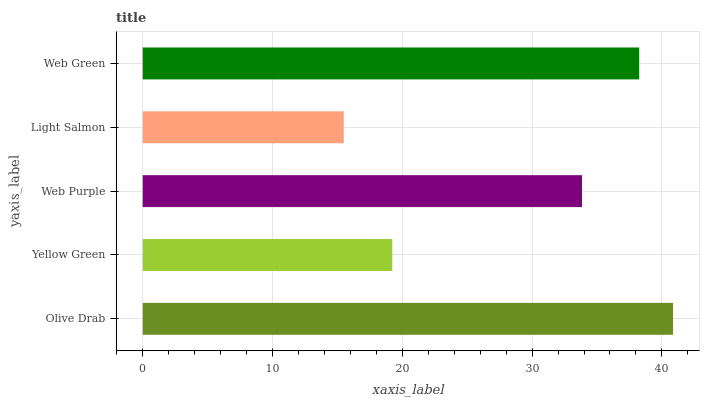Is Light Salmon the minimum?
Answer yes or no. Yes. Is Olive Drab the maximum?
Answer yes or no. Yes. Is Yellow Green the minimum?
Answer yes or no. No. Is Yellow Green the maximum?
Answer yes or no. No. Is Olive Drab greater than Yellow Green?
Answer yes or no. Yes. Is Yellow Green less than Olive Drab?
Answer yes or no. Yes. Is Yellow Green greater than Olive Drab?
Answer yes or no. No. Is Olive Drab less than Yellow Green?
Answer yes or no. No. Is Web Purple the high median?
Answer yes or no. Yes. Is Web Purple the low median?
Answer yes or no. Yes. Is Yellow Green the high median?
Answer yes or no. No. Is Yellow Green the low median?
Answer yes or no. No. 